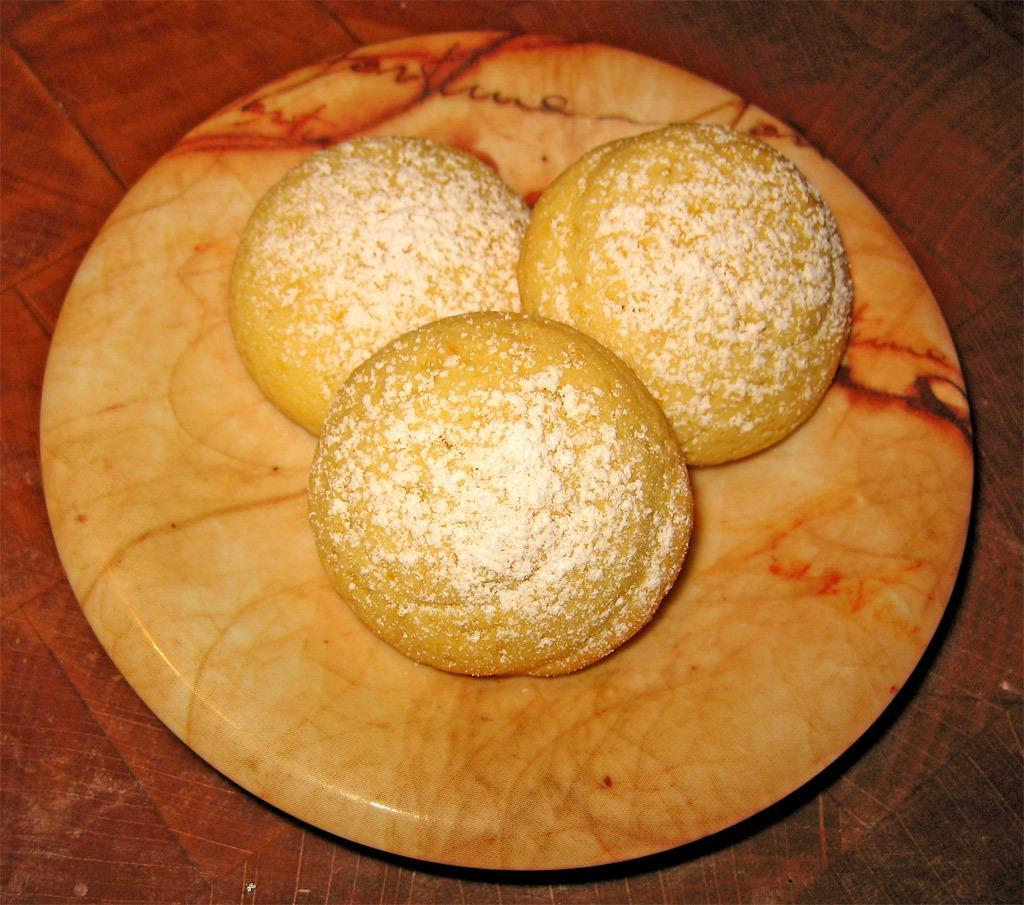How many buns are visible in the image? There are three buns in the image. Where are the buns located? The buns are placed in a plate. What surface is the plate resting on? The plate is on top of a table. What type of chickens can be seen roaming around the table in the image? There are no chickens present in the image; it only shows three buns in a plate on a table. 